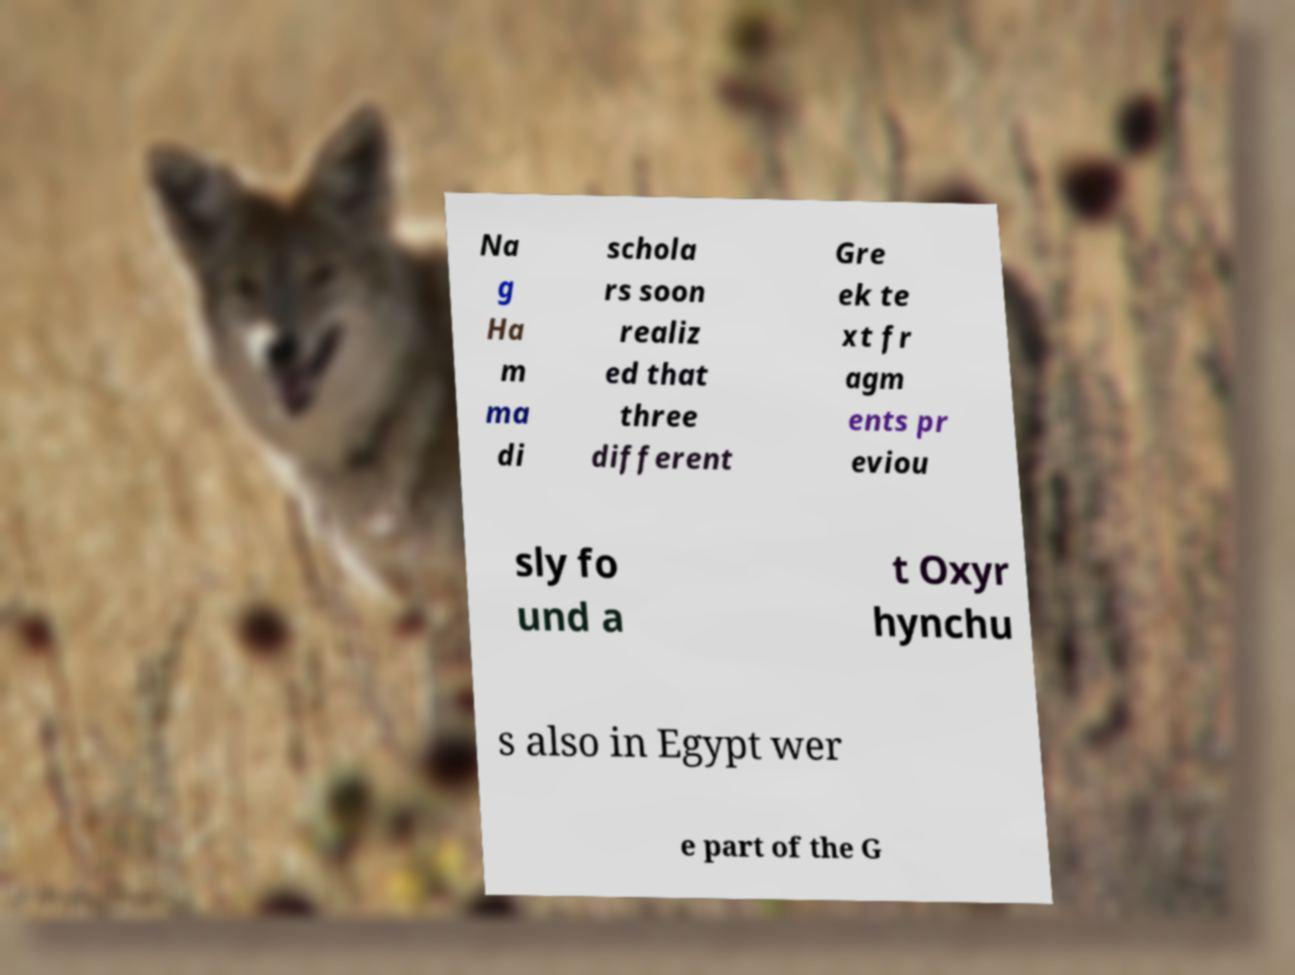There's text embedded in this image that I need extracted. Can you transcribe it verbatim? Na g Ha m ma di schola rs soon realiz ed that three different Gre ek te xt fr agm ents pr eviou sly fo und a t Oxyr hynchu s also in Egypt wer e part of the G 